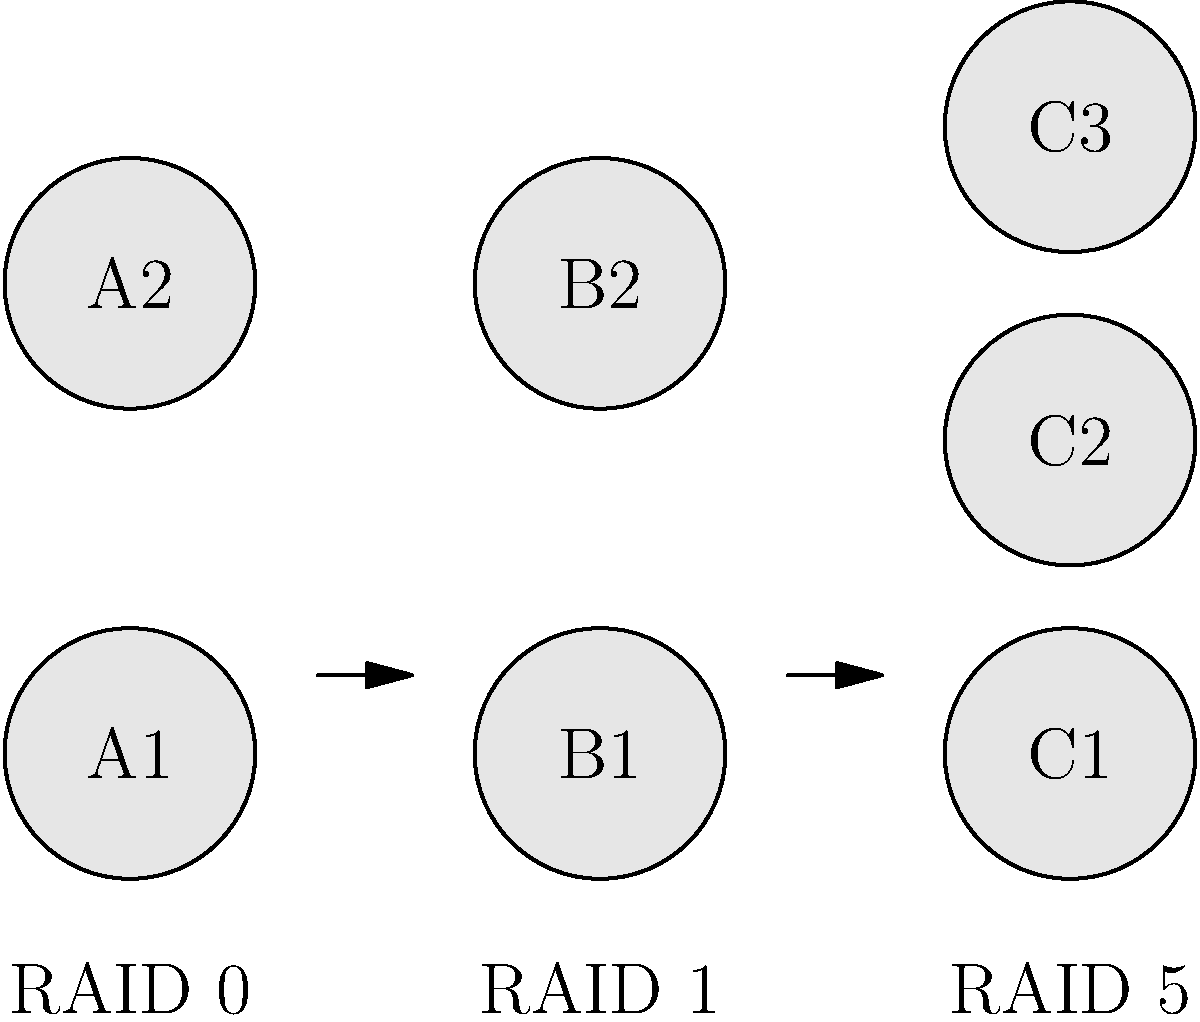As a digital marketing agency owner looking for a reliable and secure file storage solution for your clients, you're considering different RAID configurations. Based on the schematic diagram, which RAID configuration would provide the best balance between data redundancy and storage efficiency for your agency's needs? To determine the best RAID configuration for a digital marketing agency's needs, let's analyze each option:

1. RAID 0 (Striping):
   - Pros: Improves read/write performance
   - Cons: No data redundancy; if one drive fails, all data is lost
   - Not suitable for data security and reliability needs

2. RAID 1 (Mirroring):
   - Pros: Excellent data redundancy; exact copy of data on both drives
   - Cons: 50% of total storage capacity is used for redundancy
   - Good for data security but inefficient for large storage needs

3. RAID 5 (Striping with Distributed Parity):
   - Pros: 
     - Balances performance, redundancy, and storage efficiency
     - Can survive one drive failure without data loss
     - Utilizes $\frac{n-1}{n}$ of total storage capacity, where $n$ is the number of drives
   - Cons: Slightly lower write performance compared to RAID 0

For a digital marketing agency:
1. Data security is crucial for client files
2. Storage efficiency is important for managing large amounts of media files
3. Reasonable read/write performance is needed for daily operations

RAID 5 offers the best balance:
- It provides data redundancy (can survive one drive failure)
- More storage-efficient than RAID 1 (e.g., with 3 drives, $\frac{2}{3}$ of total capacity is usable)
- Better read performance than RAID 1 and better reliability than RAID 0

Therefore, RAID 5 is the most suitable configuration for the agency's needs.
Answer: RAID 5 